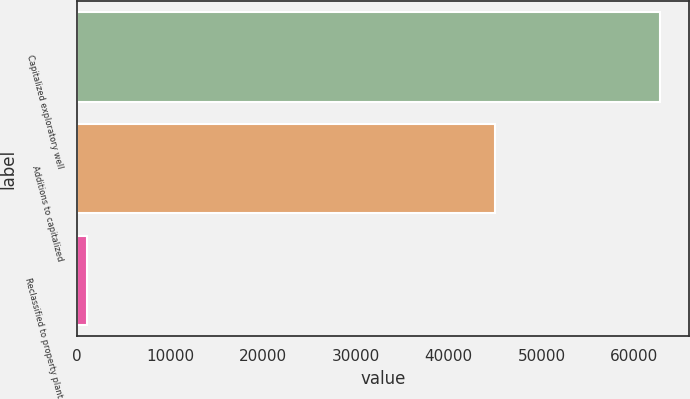Convert chart. <chart><loc_0><loc_0><loc_500><loc_500><bar_chart><fcel>Capitalized exploratory well<fcel>Additions to capitalized<fcel>Reclassified to property plant<nl><fcel>62724<fcel>45011<fcel>1061<nl></chart> 